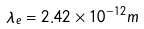<formula> <loc_0><loc_0><loc_500><loc_500>\lambda _ { e } = 2 . 4 2 \times 1 0 ^ { - 1 2 } m</formula> 